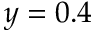Convert formula to latex. <formula><loc_0><loc_0><loc_500><loc_500>y = 0 . 4</formula> 